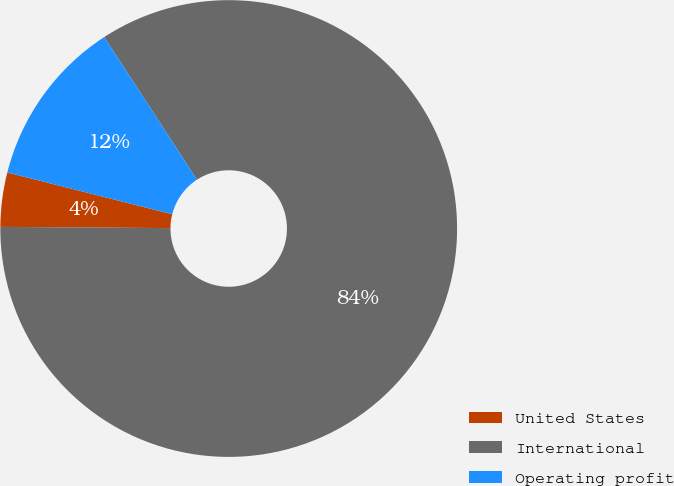Convert chart. <chart><loc_0><loc_0><loc_500><loc_500><pie_chart><fcel>United States<fcel>International<fcel>Operating profit<nl><fcel>3.83%<fcel>84.29%<fcel>11.88%<nl></chart> 